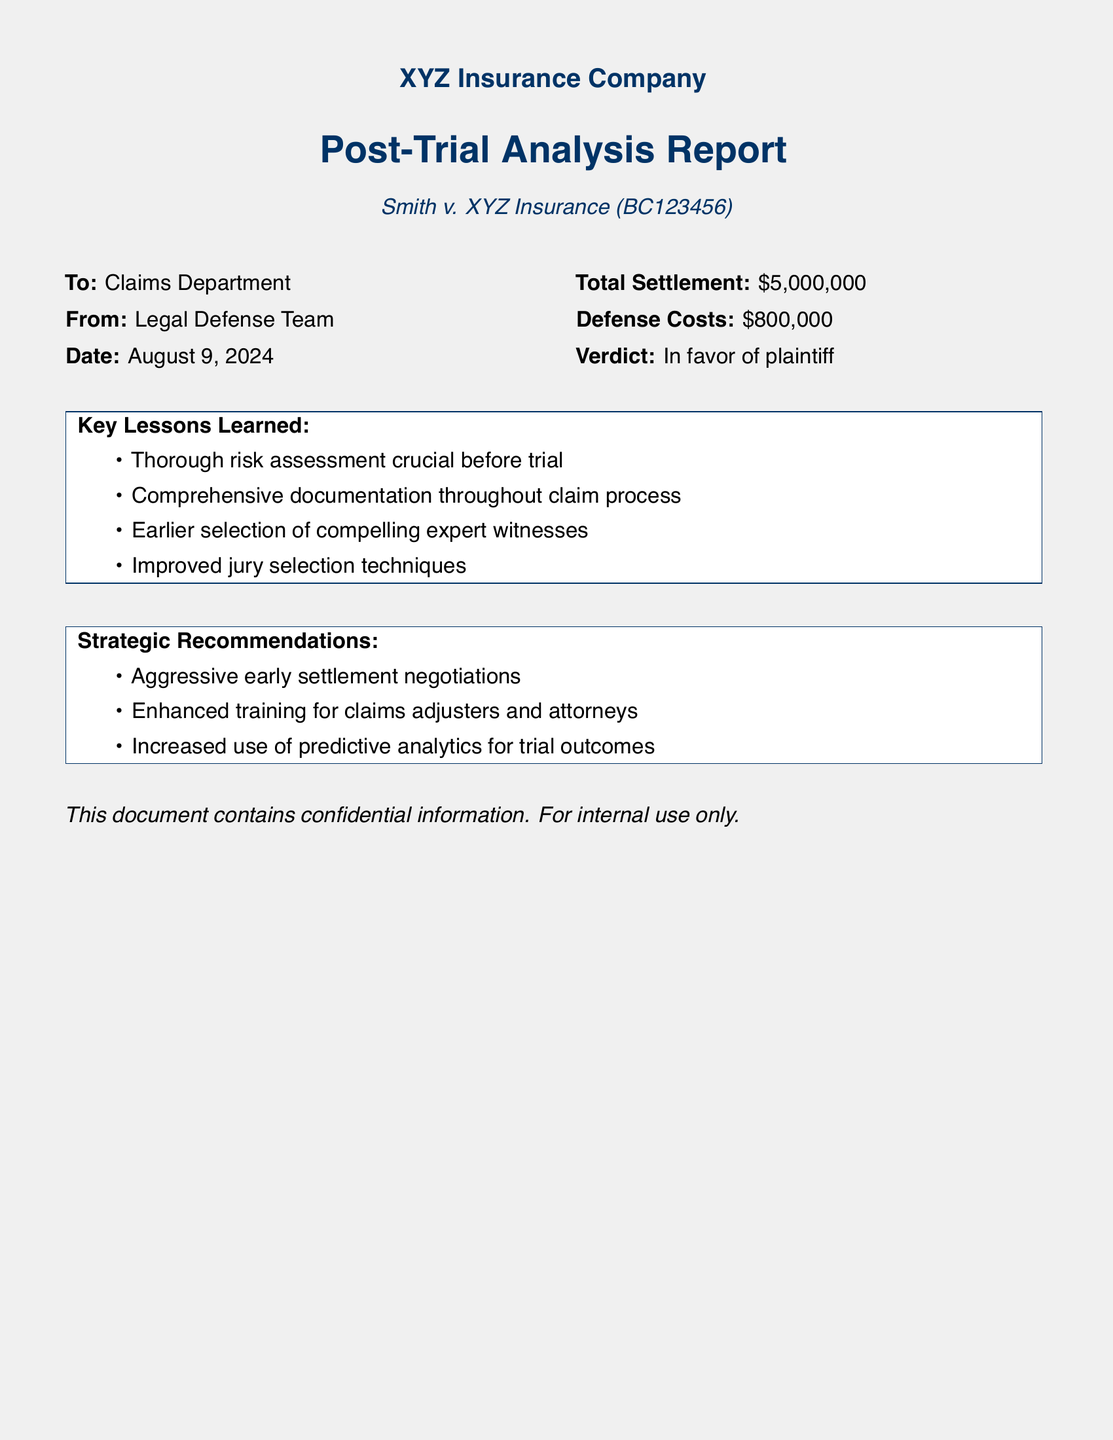What is the total settlement amount? The total settlement amount is explicitly stated in the document as the total settlement figure, which is $5,000,000.
Answer: $5,000,000 Who is the plaintiff in this case? The plaintiff's name is mentioned in the case title, which is Smith v. XYZ Insurance.
Answer: Smith What are the defense costs listed in the report? The defense costs are given clearly in the document, noted as $800,000.
Answer: $800,000 What was the verdict of the case? The verdict is highlighted explicitly, indicating the outcome was in favor of the plaintiff.
Answer: In favor of plaintiff What is one key lesson learned mentioned in the report? One key lesson learned is stated in the lessons section, emphasizing the importance of thorough risk assessment.
Answer: Thorough risk assessment crucial before trial What strategic recommendation involves negotiation? The recommendation for negotiation is identified as aggressive early settlement negotiations.
Answer: Aggressive early settlement negotiations What department is the report addressed to? The report is directed to a specific department, which can be found at the beginning of the document.
Answer: Claims Department What date is the report dated? The date of the report is noted next to "Date" in the header section of the document, which is today’s date.
Answer: today What kind of information is stated to be in this document? The type of information this document contains is specified as confidential information meant for internal use only.
Answer: confidential information 